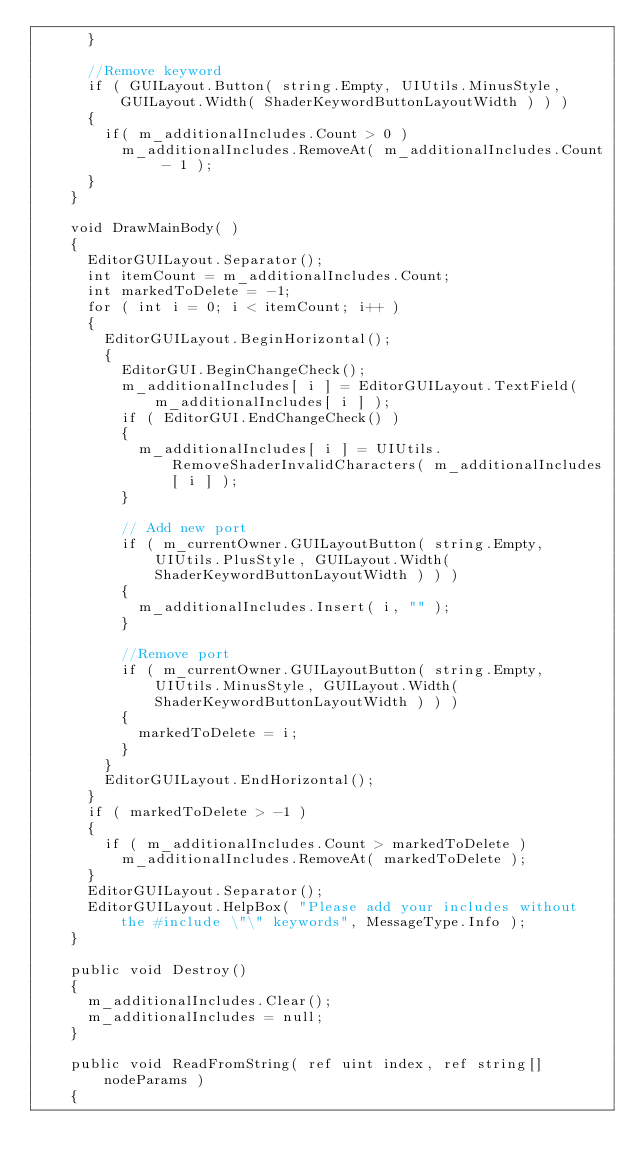Convert code to text. <code><loc_0><loc_0><loc_500><loc_500><_C#_>			}

			//Remove keyword
			if ( GUILayout.Button( string.Empty, UIUtils.MinusStyle, GUILayout.Width( ShaderKeywordButtonLayoutWidth ) ) )
			{
				if( m_additionalIncludes.Count > 0 )
					m_additionalIncludes.RemoveAt( m_additionalIncludes.Count - 1 );
			}
		}

		void DrawMainBody( )
		{
			EditorGUILayout.Separator();
			int itemCount = m_additionalIncludes.Count;
			int markedToDelete = -1;
			for ( int i = 0; i < itemCount; i++ )
			{
				EditorGUILayout.BeginHorizontal();
				{
					EditorGUI.BeginChangeCheck();
					m_additionalIncludes[ i ] = EditorGUILayout.TextField( m_additionalIncludes[ i ] );
					if ( EditorGUI.EndChangeCheck() )
					{
						m_additionalIncludes[ i ] = UIUtils.RemoveShaderInvalidCharacters( m_additionalIncludes[ i ] );
					}

					// Add new port
					if ( m_currentOwner.GUILayoutButton( string.Empty, UIUtils.PlusStyle, GUILayout.Width( ShaderKeywordButtonLayoutWidth ) ) )
					{
						m_additionalIncludes.Insert( i, "" );
					}

					//Remove port
					if ( m_currentOwner.GUILayoutButton( string.Empty, UIUtils.MinusStyle, GUILayout.Width( ShaderKeywordButtonLayoutWidth ) ) )
					{
						markedToDelete = i;
					}
				}
				EditorGUILayout.EndHorizontal();
			}
			if ( markedToDelete > -1 )
			{
				if ( m_additionalIncludes.Count > markedToDelete )
					m_additionalIncludes.RemoveAt( markedToDelete );
			}
			EditorGUILayout.Separator();
			EditorGUILayout.HelpBox( "Please add your includes without the #include \"\" keywords", MessageType.Info );
		}

		public void Destroy()
		{
			m_additionalIncludes.Clear();
			m_additionalIncludes = null;
		}

		public void ReadFromString( ref uint index, ref string[] nodeParams )
		{</code> 